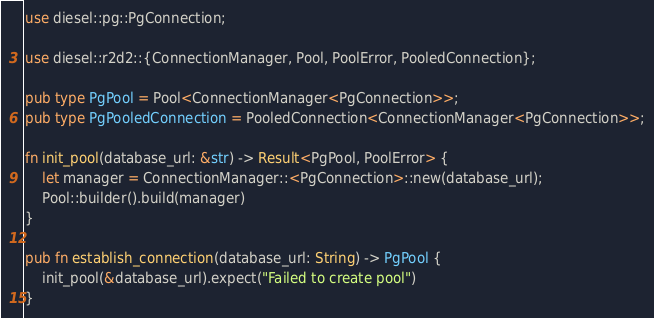<code> <loc_0><loc_0><loc_500><loc_500><_Rust_>use diesel::pg::PgConnection;

use diesel::r2d2::{ConnectionManager, Pool, PoolError, PooledConnection};

pub type PgPool = Pool<ConnectionManager<PgConnection>>;
pub type PgPooledConnection = PooledConnection<ConnectionManager<PgConnection>>;

fn init_pool(database_url: &str) -> Result<PgPool, PoolError> {
    let manager = ConnectionManager::<PgConnection>::new(database_url);
    Pool::builder().build(manager)
}

pub fn establish_connection(database_url: String) -> PgPool {
    init_pool(&database_url).expect("Failed to create pool")
}
</code> 